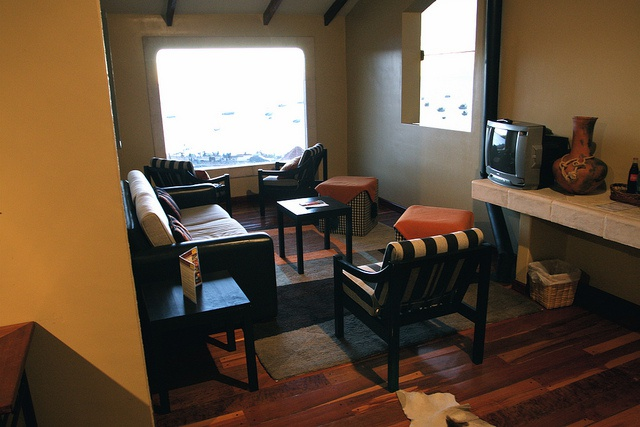Describe the objects in this image and their specific colors. I can see tv in olive, white, gray, darkgray, and lightblue tones, chair in olive, black, and maroon tones, couch in olive, black, white, maroon, and darkgray tones, chair in olive, black, white, gray, and maroon tones, and vase in olive, black, maroon, and brown tones in this image. 